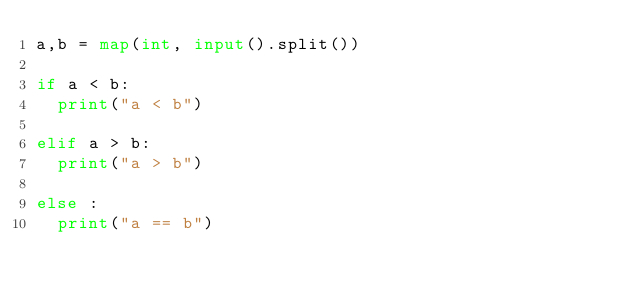<code> <loc_0><loc_0><loc_500><loc_500><_Python_>a,b = map(int, input().split())

if a < b:
  print("a < b")

elif a > b:
  print("a > b")

else :
  print("a == b")

</code> 